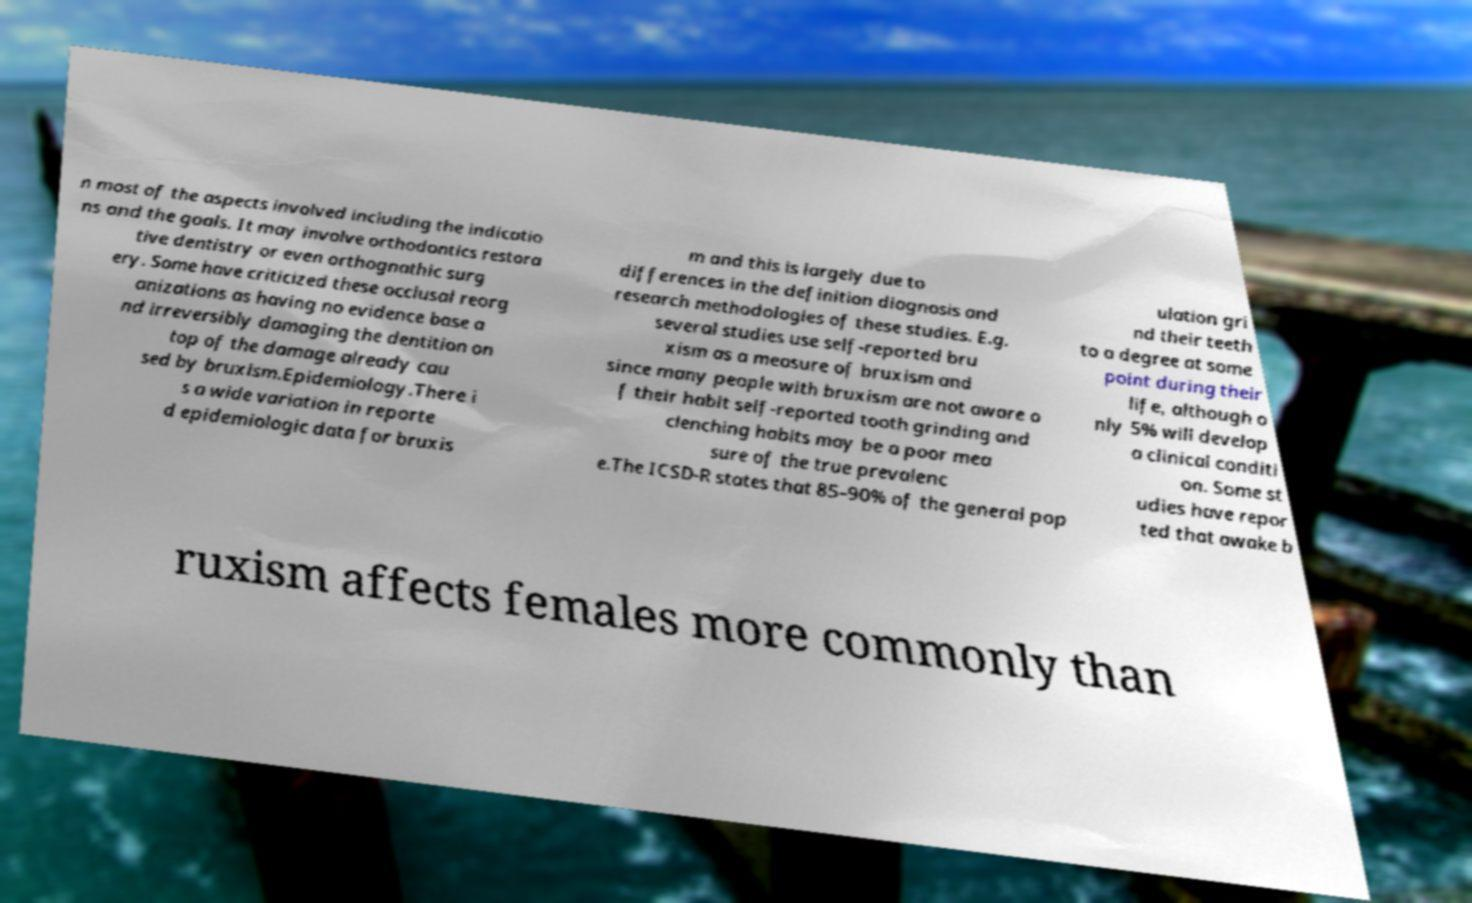Can you read and provide the text displayed in the image?This photo seems to have some interesting text. Can you extract and type it out for me? n most of the aspects involved including the indicatio ns and the goals. It may involve orthodontics restora tive dentistry or even orthognathic surg ery. Some have criticized these occlusal reorg anizations as having no evidence base a nd irreversibly damaging the dentition on top of the damage already cau sed by bruxism.Epidemiology.There i s a wide variation in reporte d epidemiologic data for bruxis m and this is largely due to differences in the definition diagnosis and research methodologies of these studies. E.g. several studies use self-reported bru xism as a measure of bruxism and since many people with bruxism are not aware o f their habit self-reported tooth grinding and clenching habits may be a poor mea sure of the true prevalenc e.The ICSD-R states that 85–90% of the general pop ulation gri nd their teeth to a degree at some point during their life, although o nly 5% will develop a clinical conditi on. Some st udies have repor ted that awake b ruxism affects females more commonly than 